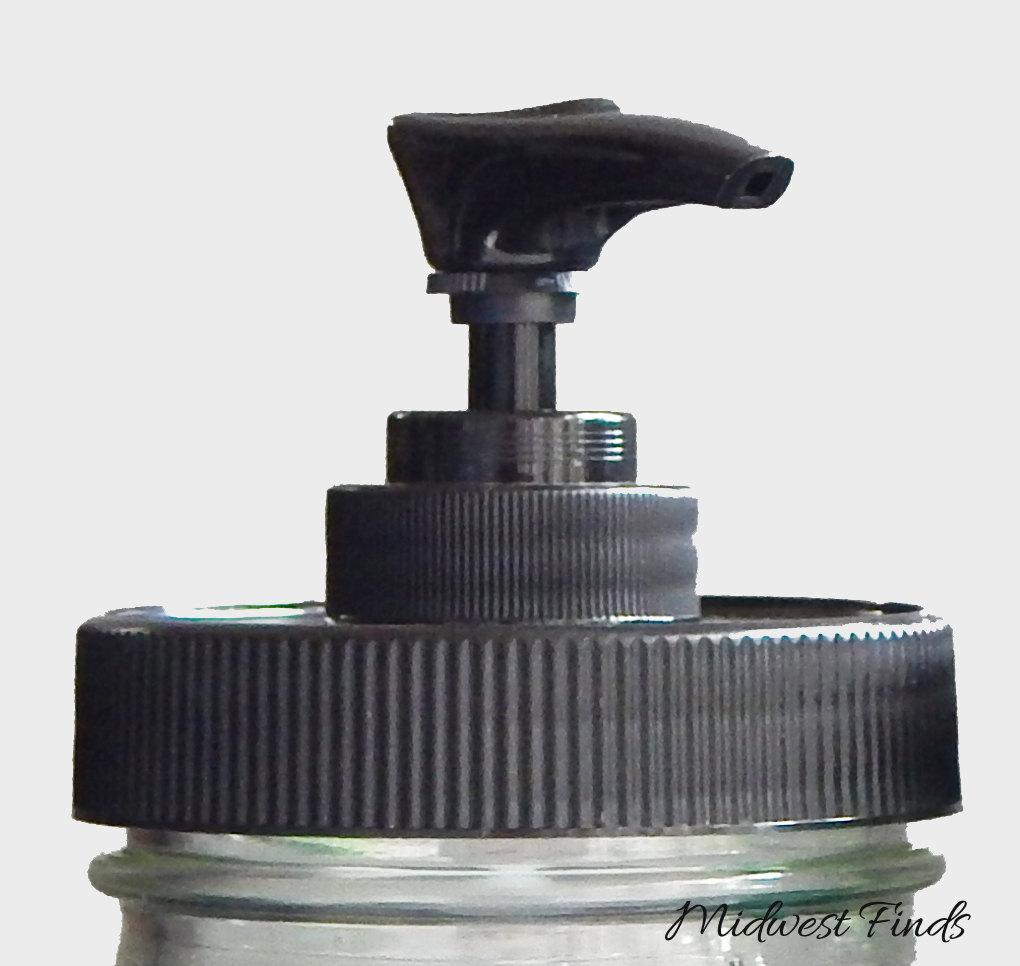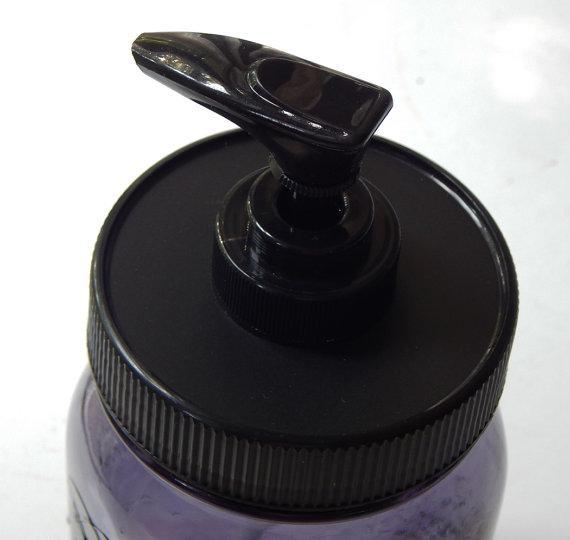The first image is the image on the left, the second image is the image on the right. Considering the images on both sides, is "The right image contains a black dispenser with a chrome top." valid? Answer yes or no. No. The first image is the image on the left, the second image is the image on the right. Evaluate the accuracy of this statement regarding the images: "The pump on one bottle has a spout that emerges horizontally, but then angles downward slightly, while the pump of the other bottle is horizontal with no angle.". Is it true? Answer yes or no. No. 